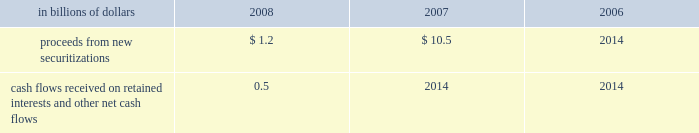Application of specific accounting literature .
For the nonconsolidated proprietary tob trusts and qspe tob trusts , the company recognizes only its residual investment on its balance sheet at fair value and the third-party financing raised by the trusts is off-balance sheet .
The table summarizes selected cash flow information related to municipal bond securitizations for the years 2008 , 2007 and 2006 : in billions of dollars 2008 2007 2006 .
Cash flows received on retained interests and other net cash flows 0.5 2014 2014 municipal investments municipal investment transactions represent partnerships that finance the construction and rehabilitation of low-income affordable rental housing .
The company generally invests in these partnerships as a limited partner and earns a return primarily through the receipt of tax credits earned from the affordable housing investments made by the partnership .
Client intermediation client intermediation transactions represent a range of transactions designed to provide investors with specified returns based on the returns of an underlying security , referenced asset or index .
These transactions include credit-linked notes and equity-linked notes .
In these transactions , the spe typically obtains exposure to the underlying security , referenced asset or index through a derivative instrument , such as a total-return swap or a credit-default swap .
In turn the spe issues notes to investors that pay a return based on the specified underlying security , referenced asset or index .
The spe invests the proceeds in a financial asset or a guaranteed insurance contract ( gic ) that serves as collateral for the derivative contract over the term of the transaction .
The company 2019s involvement in these transactions includes being the counterparty to the spe 2019s derivative instruments and investing in a portion of the notes issued by the spe .
In certain transactions , the investor 2019s maximum risk of loss is limited and the company absorbs risk of loss above a specified level .
The company 2019s maximum risk of loss in these transactions is defined as the amount invested in notes issued by the spe and the notional amount of any risk of loss absorbed by the company through a separate instrument issued by the spe .
The derivative instrument held by the company may generate a receivable from the spe ( for example , where the company purchases credit protection from the spe in connection with the spe 2019s issuance of a credit-linked note ) , which is collateralized by the assets owned by the spe .
These derivative instruments are not considered variable interests under fin 46 ( r ) and any associated receivables are not included in the calculation of maximum exposure to the spe .
Structured investment vehicles structured investment vehicles ( sivs ) are spes that issue junior notes and senior debt ( medium-term notes and short-term commercial paper ) to fund the purchase of high quality assets .
The junior notes are subject to the 201cfirst loss 201d risk of the sivs .
The sivs provide a variable return to the junior note investors based on the net spread between the cost to issue the senior debt and the return realized by the high quality assets .
The company acts as manager for the sivs and , prior to december 13 , 2007 , was not contractually obligated to provide liquidity facilities or guarantees to the sivs .
In response to the ratings review of the outstanding senior debt of the sivs for a possible downgrade announced by two ratings agencies and the continued reduction of liquidity in the siv-related asset-backed commercial paper and medium-term note markets , on december 13 , 2007 , citigroup announced its commitment to provide support facilities that would support the sivs 2019 senior debt ratings .
As a result of this commitment , citigroup became the sivs 2019 primary beneficiary and began consolidating these entities .
On february 12 , 2008 , citigroup finalized the terms of the support facilities , which took the form of a commitment to provide $ 3.5 billion of mezzanine capital to the sivs in the event the market value of their junior notes approaches zero .
The mezzanine capital facility was increased by $ 1 billion to $ 4.5 billion , with the additional commitment funded during the fourth quarter of 2008 .
The facilities rank senior to the junior notes but junior to the commercial paper and medium-term notes .
The facilities were at arm 2019s-length terms .
Interest was paid on the drawn amount of the facilities and a per annum fee was paid on the unused portion .
During the period to november 18 , 2008 , the company wrote down $ 3.3 billion on siv assets .
In order to complete the wind-down of the sivs , the company , in a nearly cashless transaction , purchased the remaining assets of the sivs at fair value , with a trade date of november 18 , 2008 .
The company funded the purchase of the siv assets by assuming the obligation to pay amounts due under the medium-term notes issued by the sivs , as the medium-term notes mature .
The net funding provided by the company to fund the purchase of the siv assets was $ 0.3 billion .
As of december 31 , 2008 , the carrying amount of the purchased siv assets was $ 16.6 billion , of which $ 16.5 billion is classified as htm assets .
Investment funds the company is the investment manager for certain investment funds that invest in various asset classes including private equity , hedge funds , real estate , fixed income and infrastructure .
The company earns a management fee , which is a percentage of capital under management , and may earn performance fees .
In addition , for some of these funds the company has an ownership interest in the investment funds .
The company has also established a number of investment funds as opportunities for qualified employees to invest in private equity investments .
The company acts as investment manager to these funds and may provide employees with financing on both a recourse and non-recourse basis for a portion of the employees 2019 investment commitments. .
What was the change in billion of proceeds from new securitizations from 2007 to 2008 in billions? 
Computations: (1.2 - 10.5)
Answer: -9.3. 